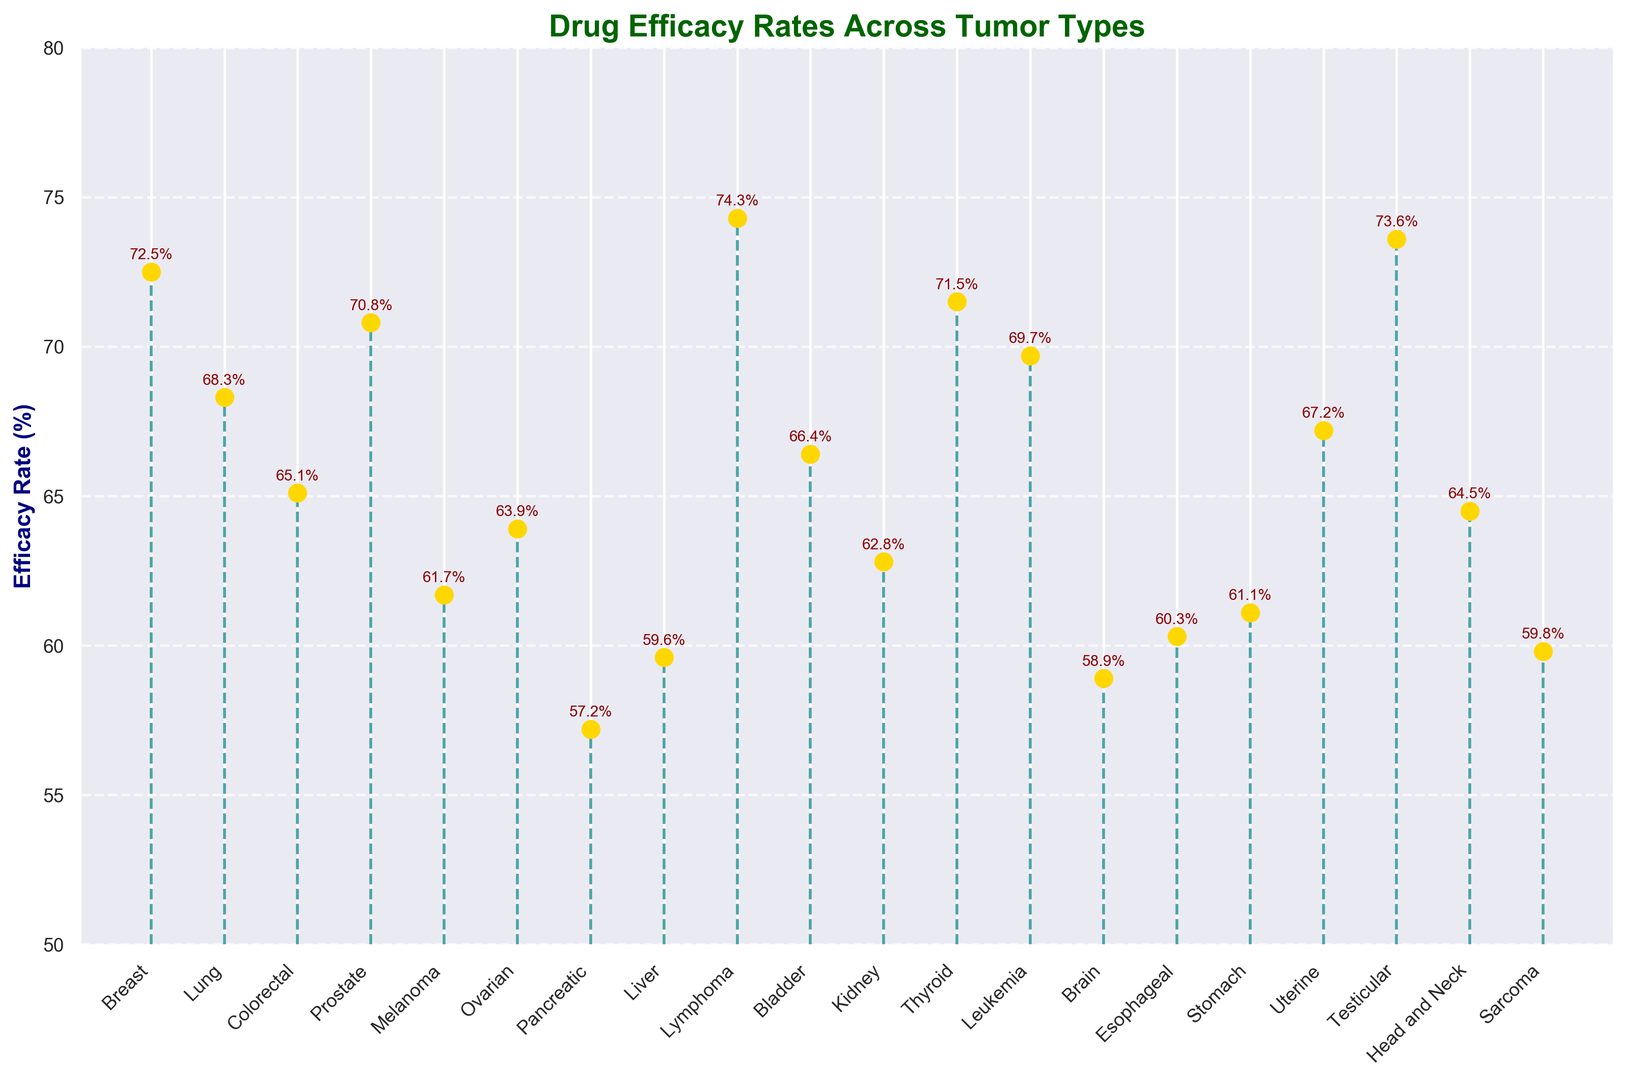Which tumor type has the highest efficacy rate? First, identify the tumor type with the highest efficacy rate marker. By comparing all the efficacy rates on the stem plot, Lymphoma has the highest rate at 74.3%.
Answer: Lymphoma What is the difference in efficacy rate between Liver and Pancreatic tumors? Locate the markers for Liver and Pancreatic tumors and note their efficacy rates (Liver: 59.6%, Pancreatic: 57.2%). Subtract the smaller rate from the larger rate, giving 59.6 - 57.2.
Answer: 2.4% Which tumor types have efficacy rates above 70%? Identify and list the tumor types whose efficacy rate markers are above the 70% mark. The eligible tumors are Breast (72.5%), Prostate (70.8%), Lymphoma (74.3%), Thyroid (71.5%), and Testicular (73.6%).
Answer: Breast, Prostate, Lymphoma, Thyroid, Testicular What is the average efficacy rate across all tumor types? Sum all the efficacy rates and divide by the number of tumor types. The total sum is 1262.6, and there are 20 tumor types, so the average is 1262.6/20.
Answer: 63.13% Which tumor type has the lowest efficacy rate and what is its value? Identify the tumor type with the marker closest to the base of the plot, indicating the lowest efficacy rate. Pancreatic tumor has the lowest rate at 57.2%.
Answer: Pancreatic, 57.2% How does the efficacy rate of Leukemia compare to that of Lung cancer? Identify the efficacy rates for Leukemia (69.7%) and Lung cancer (68.3%). Compare by calculating the difference, 69.7 - 68.3.
Answer: Leukemia is 1.4% higher than Lung cancer Which tumor type has an efficacy rate closest to 65%? Identify the tumor type whose marker is nearest to the 65% efficacy rate. Colorectal cancer has a rate of 65.1%, which is closest to 65%.
Answer: Colorectal What is the range of efficacy rates for the tumor types shown? Determine the highest and lowest efficacy rates from the plot (Highest: Lymphoma 74.3%, Lowest: Pancreatic 57.2%). Subtract the lowest from the highest, 74.3 - 57.2.
Answer: 17.1% How many tumor types have efficacy rates below 60%? Count the tumor type markers that are below the 60% mark. The relevant tumors are Pancreatic (57.2%), Brain (58.9%), Sarcoma (59.8%), Liver (59.6%), and Esophageal (60.3%) but rounded down. The count is 4.
Answer: 4 Compare the efficacy rates of Breast and Prostate tumors. Which one is higher and by how much? Locate and compare the markers for Breast (72.5%) and Prostate (70.8%). Subtract the smaller from the larger, 72.5 - 70.8.
Answer: Breast is 1.7% higher than Prostate 